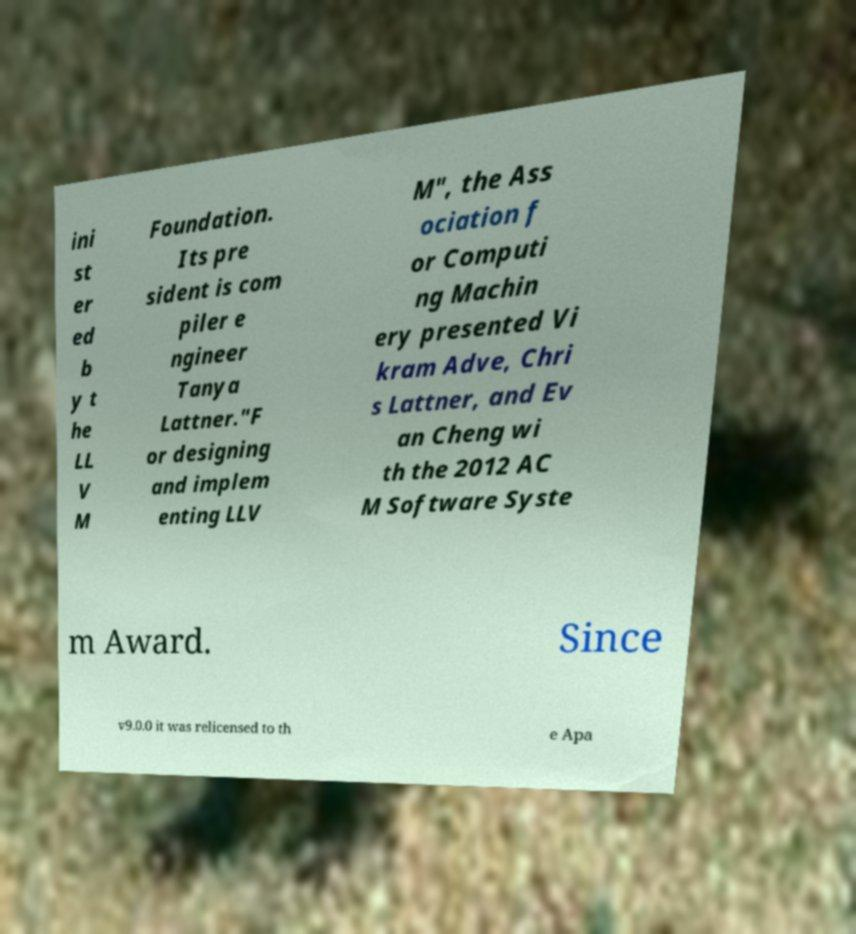What messages or text are displayed in this image? I need them in a readable, typed format. ini st er ed b y t he LL V M Foundation. Its pre sident is com piler e ngineer Tanya Lattner."F or designing and implem enting LLV M", the Ass ociation f or Computi ng Machin ery presented Vi kram Adve, Chri s Lattner, and Ev an Cheng wi th the 2012 AC M Software Syste m Award. Since v9.0.0 it was relicensed to th e Apa 